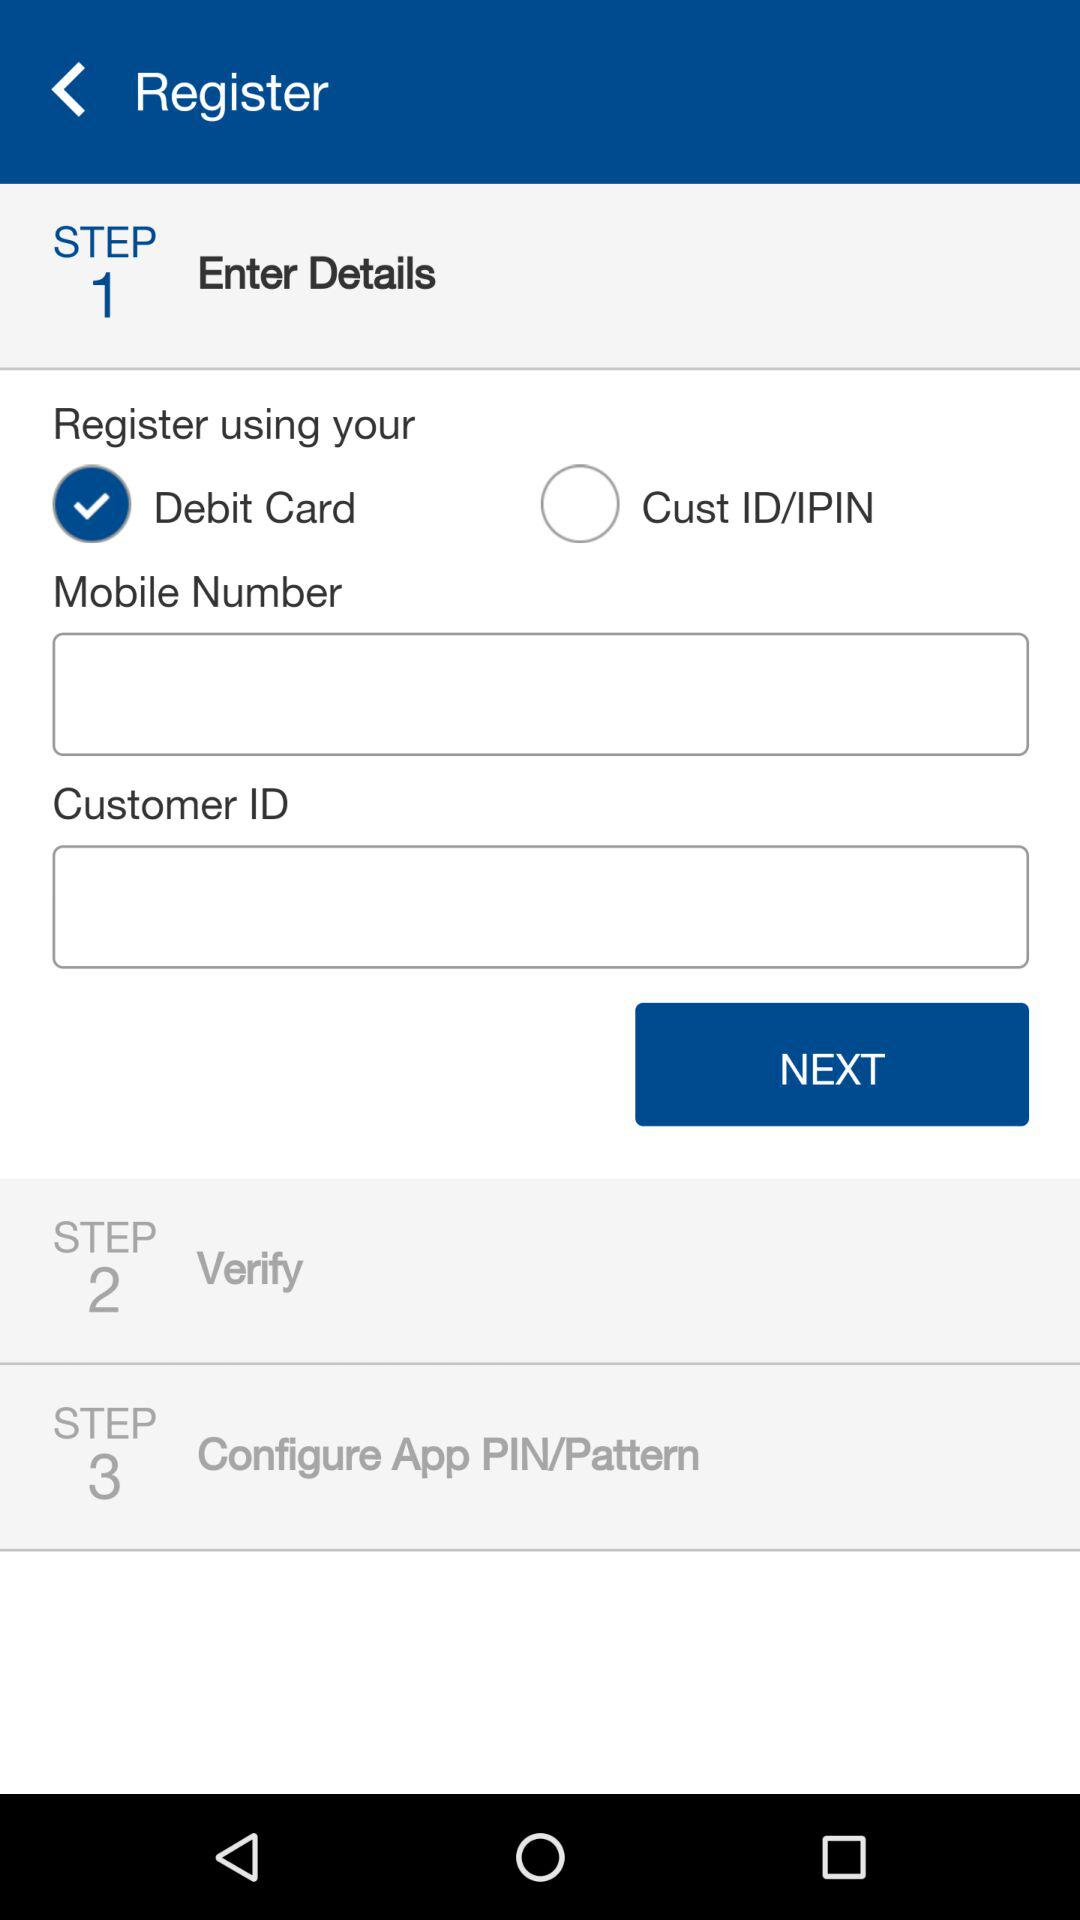How many steps are there in this process?
Answer the question using a single word or phrase. 3 